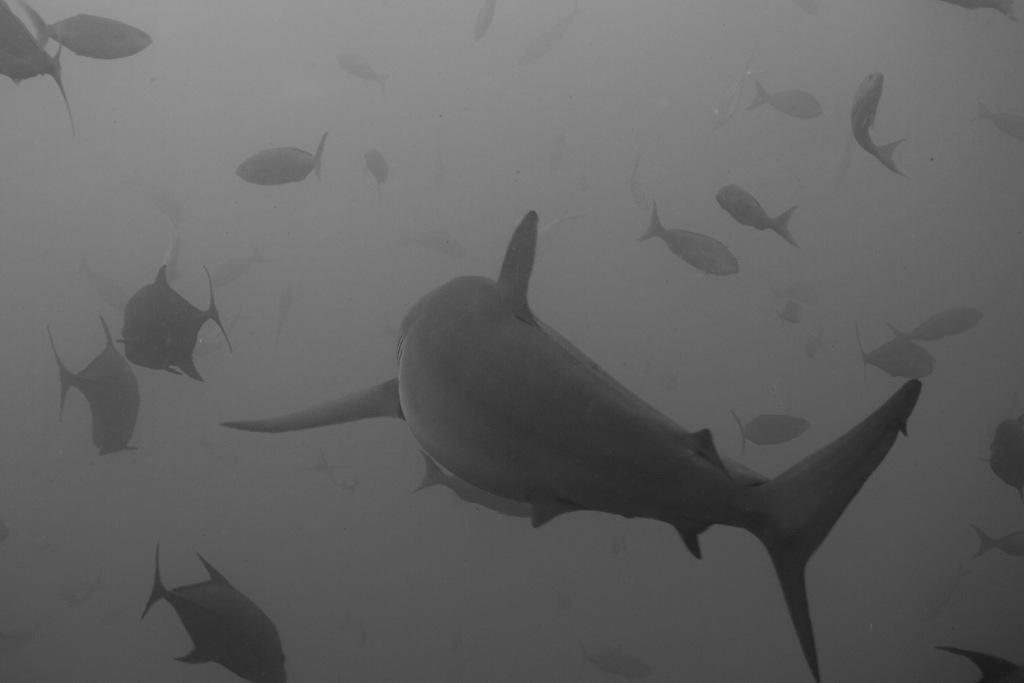What type of animals can be seen in the image? There are fishes in the image. What are the fishes doing in the image? The fishes are swimming in the water. What is the color scheme of the image? The image is black and white. How many people are in the crowd depicted in the image? There is no crowd present in the image; it features fishes swimming in the water. What type of work does the secretary perform in the image? There is no secretary present in the image; it features fishes swimming in the water. 